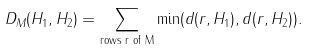<formula> <loc_0><loc_0><loc_500><loc_500>D _ { M } ( H _ { 1 } , H _ { 2 } ) = \sum _ { \text {rows r of M} } \min ( d ( r , H _ { 1 } ) , d ( r , H _ { 2 } ) ) .</formula> 